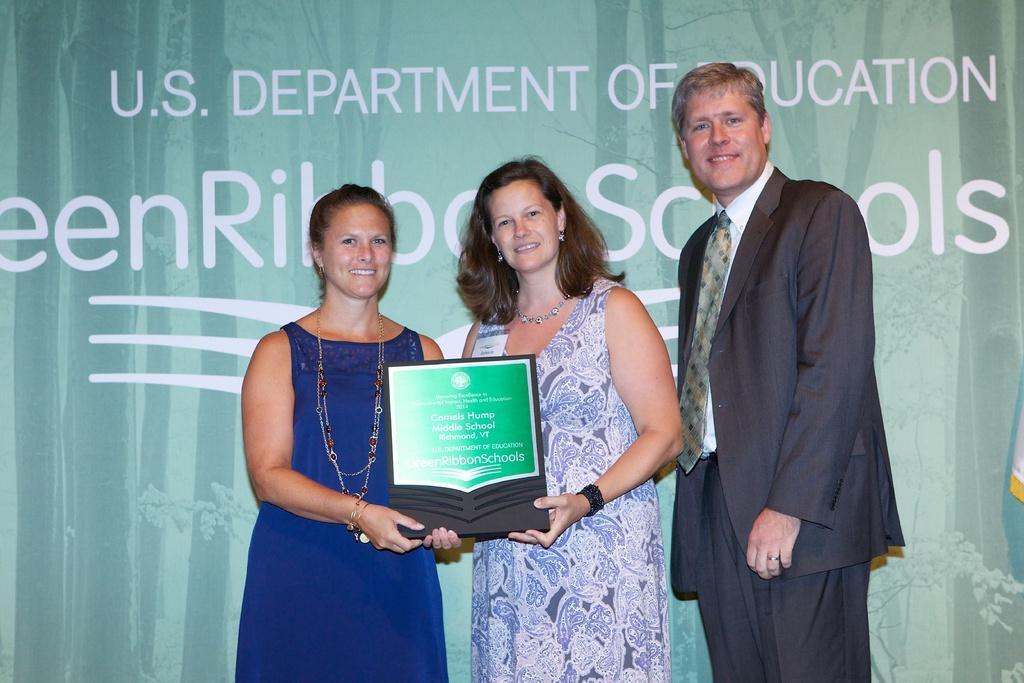Please provide a concise description of this image. In this image we can see two women and a man. They are smiling. Here we can see two women are holding a trophy with their hands. In the background we can see a banner and there is text written on it. 